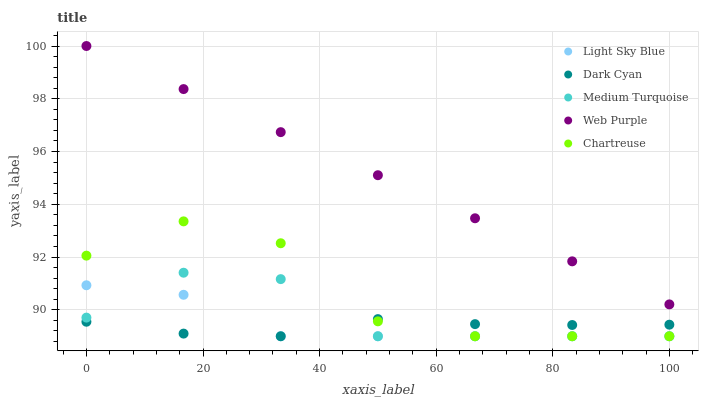Does Dark Cyan have the minimum area under the curve?
Answer yes or no. Yes. Does Web Purple have the maximum area under the curve?
Answer yes or no. Yes. Does Light Sky Blue have the minimum area under the curve?
Answer yes or no. No. Does Light Sky Blue have the maximum area under the curve?
Answer yes or no. No. Is Web Purple the smoothest?
Answer yes or no. Yes. Is Chartreuse the roughest?
Answer yes or no. Yes. Is Light Sky Blue the smoothest?
Answer yes or no. No. Is Light Sky Blue the roughest?
Answer yes or no. No. Does Dark Cyan have the lowest value?
Answer yes or no. Yes. Does Web Purple have the lowest value?
Answer yes or no. No. Does Web Purple have the highest value?
Answer yes or no. Yes. Does Light Sky Blue have the highest value?
Answer yes or no. No. Is Chartreuse less than Web Purple?
Answer yes or no. Yes. Is Web Purple greater than Chartreuse?
Answer yes or no. Yes. Does Chartreuse intersect Light Sky Blue?
Answer yes or no. Yes. Is Chartreuse less than Light Sky Blue?
Answer yes or no. No. Is Chartreuse greater than Light Sky Blue?
Answer yes or no. No. Does Chartreuse intersect Web Purple?
Answer yes or no. No. 